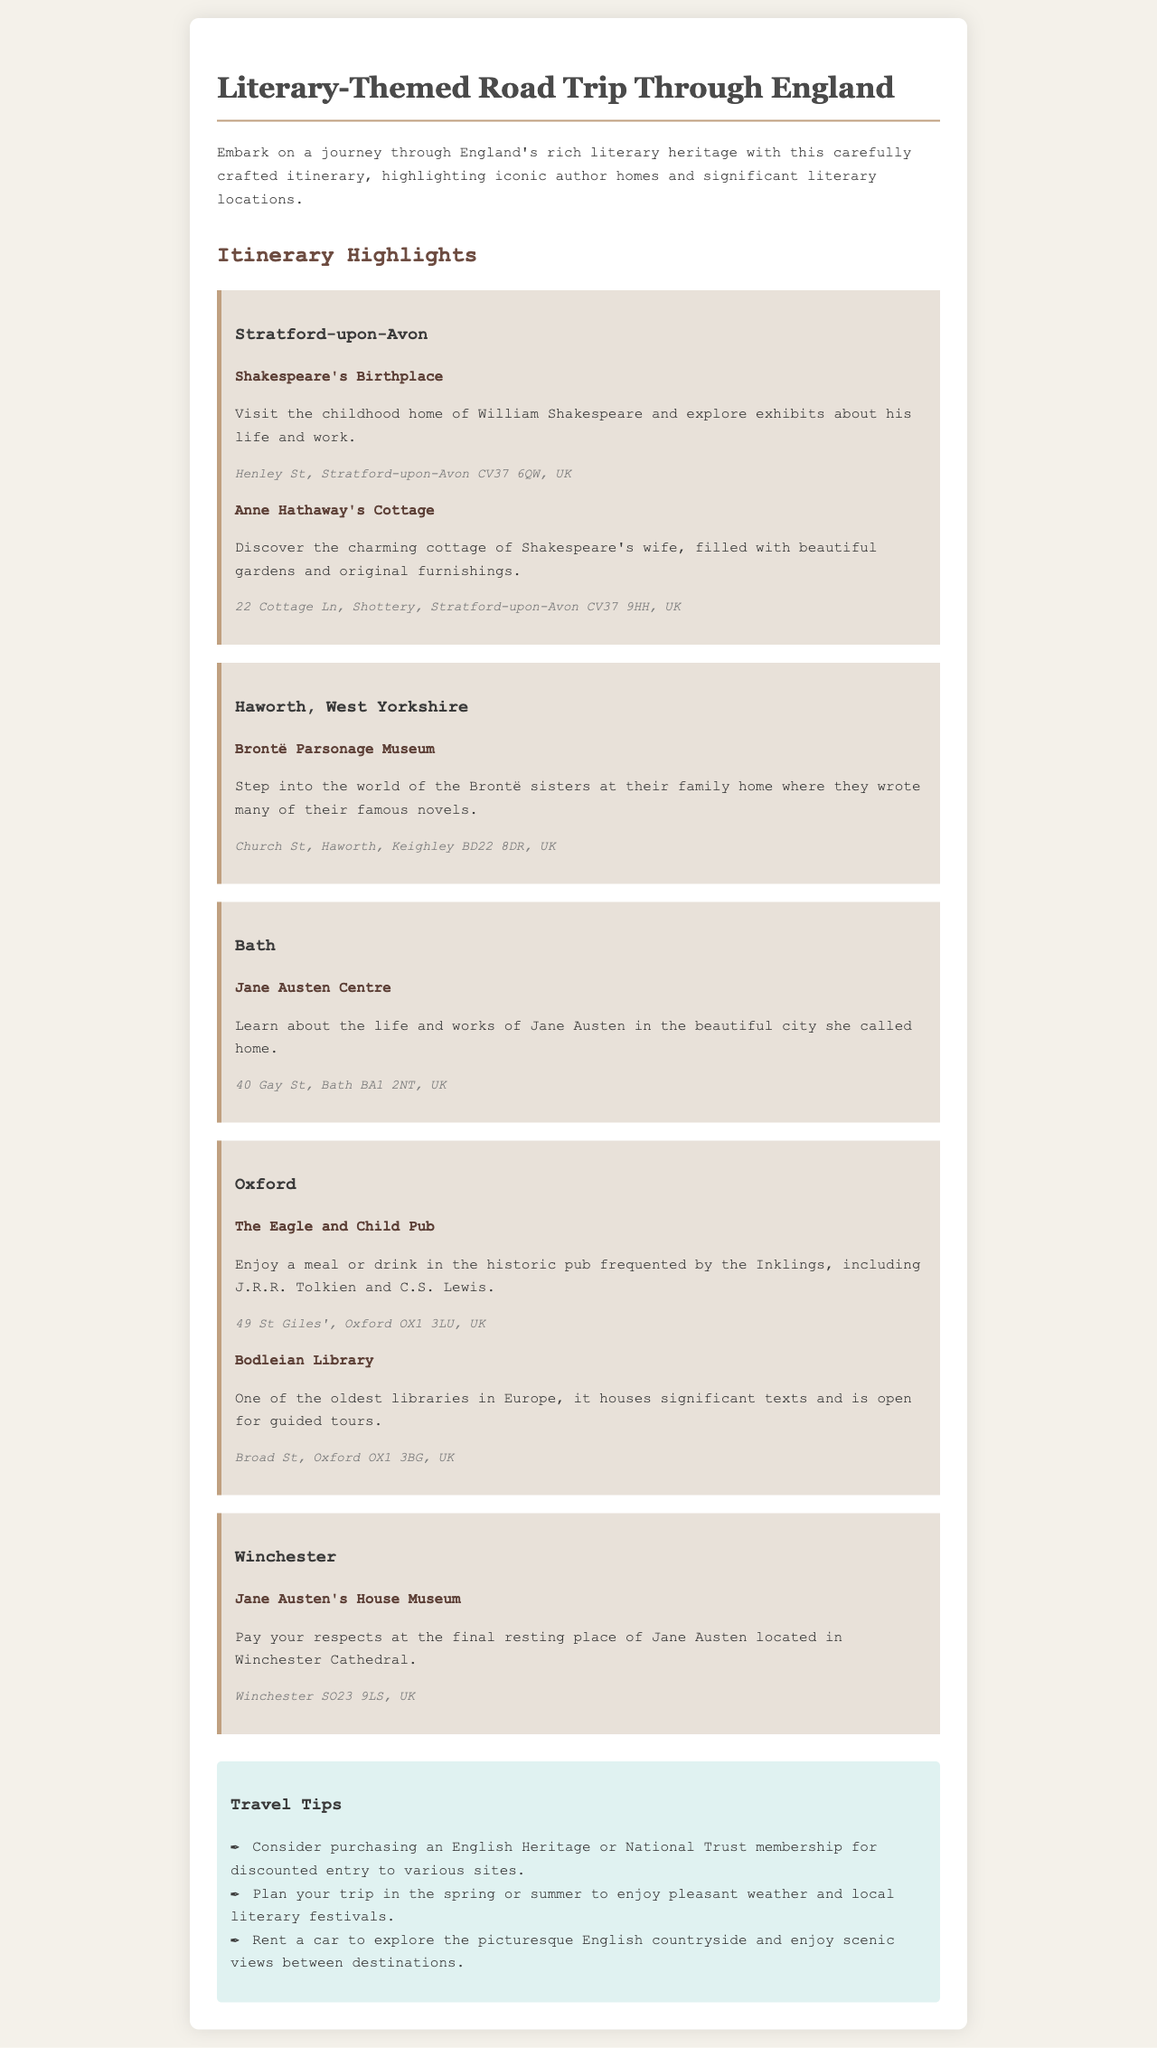what is the name of Shakespeare's birthplace? The document mentions "Shakespeare's Birthplace" as the place to visit in Stratford-upon-Avon.
Answer: Shakespeare's Birthplace where is the Brontë Parsonage Museum located? The location provides the address for the Brontë Parsonage Museum, which is in Haworth, West Yorkshire.
Answer: Church St, Haworth, Keighley BD22 8DR, UK which two authors frequented The Eagle and Child Pub? The document states that The Eagle and Child Pub was frequented by J.R.R. Tolkien and C.S. Lewis.
Answer: J.R.R. Tolkien and C.S. Lewis what is a recommended tip for visiting these literary sites? The travel tips section suggests purchasing an English Heritage or National Trust membership for discounted entry.
Answer: Purchase an English Heritage or National Trust membership what is located at Winchester Cathedral? The document indicates that Jane Austen's final resting place is at Winchester Cathedral.
Answer: Jane Austen's House Museum what is the main focus of the itinerary? The itinerary focuses on visiting iconic author homes and significant literary locations throughout England.
Answer: Iconic author homes and significant literary locations how many attractions are listed in Stratford-upon-Avon? The document lists two attractions in Stratford-upon-Avon: Shakespeare's Birthplace and Anne Hathaway's Cottage.
Answer: Two attractions what travel tip suggests planning your trip for specific weather? The document advises planning the trip in spring or summer for pleasant weather and local literary festivals.
Answer: Spring or summer 